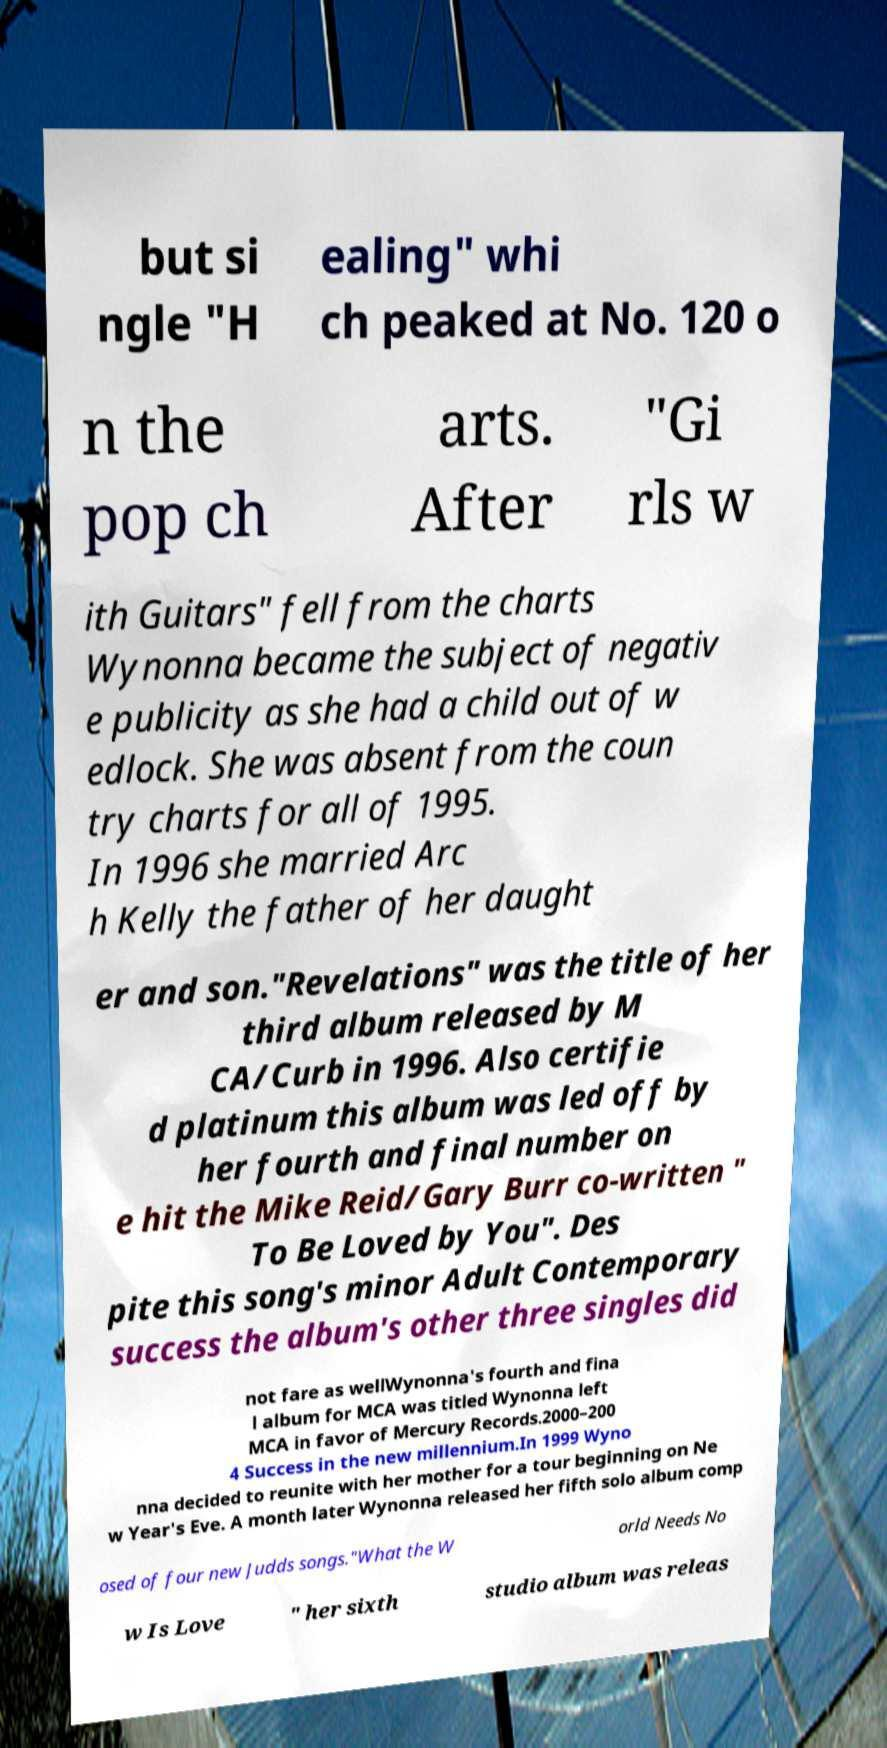Please read and relay the text visible in this image. What does it say? but si ngle "H ealing" whi ch peaked at No. 120 o n the pop ch arts. After "Gi rls w ith Guitars" fell from the charts Wynonna became the subject of negativ e publicity as she had a child out of w edlock. She was absent from the coun try charts for all of 1995. In 1996 she married Arc h Kelly the father of her daught er and son."Revelations" was the title of her third album released by M CA/Curb in 1996. Also certifie d platinum this album was led off by her fourth and final number on e hit the Mike Reid/Gary Burr co-written " To Be Loved by You". Des pite this song's minor Adult Contemporary success the album's other three singles did not fare as wellWynonna's fourth and fina l album for MCA was titled Wynonna left MCA in favor of Mercury Records.2000–200 4 Success in the new millennium.In 1999 Wyno nna decided to reunite with her mother for a tour beginning on Ne w Year's Eve. A month later Wynonna released her fifth solo album comp osed of four new Judds songs."What the W orld Needs No w Is Love " her sixth studio album was releas 